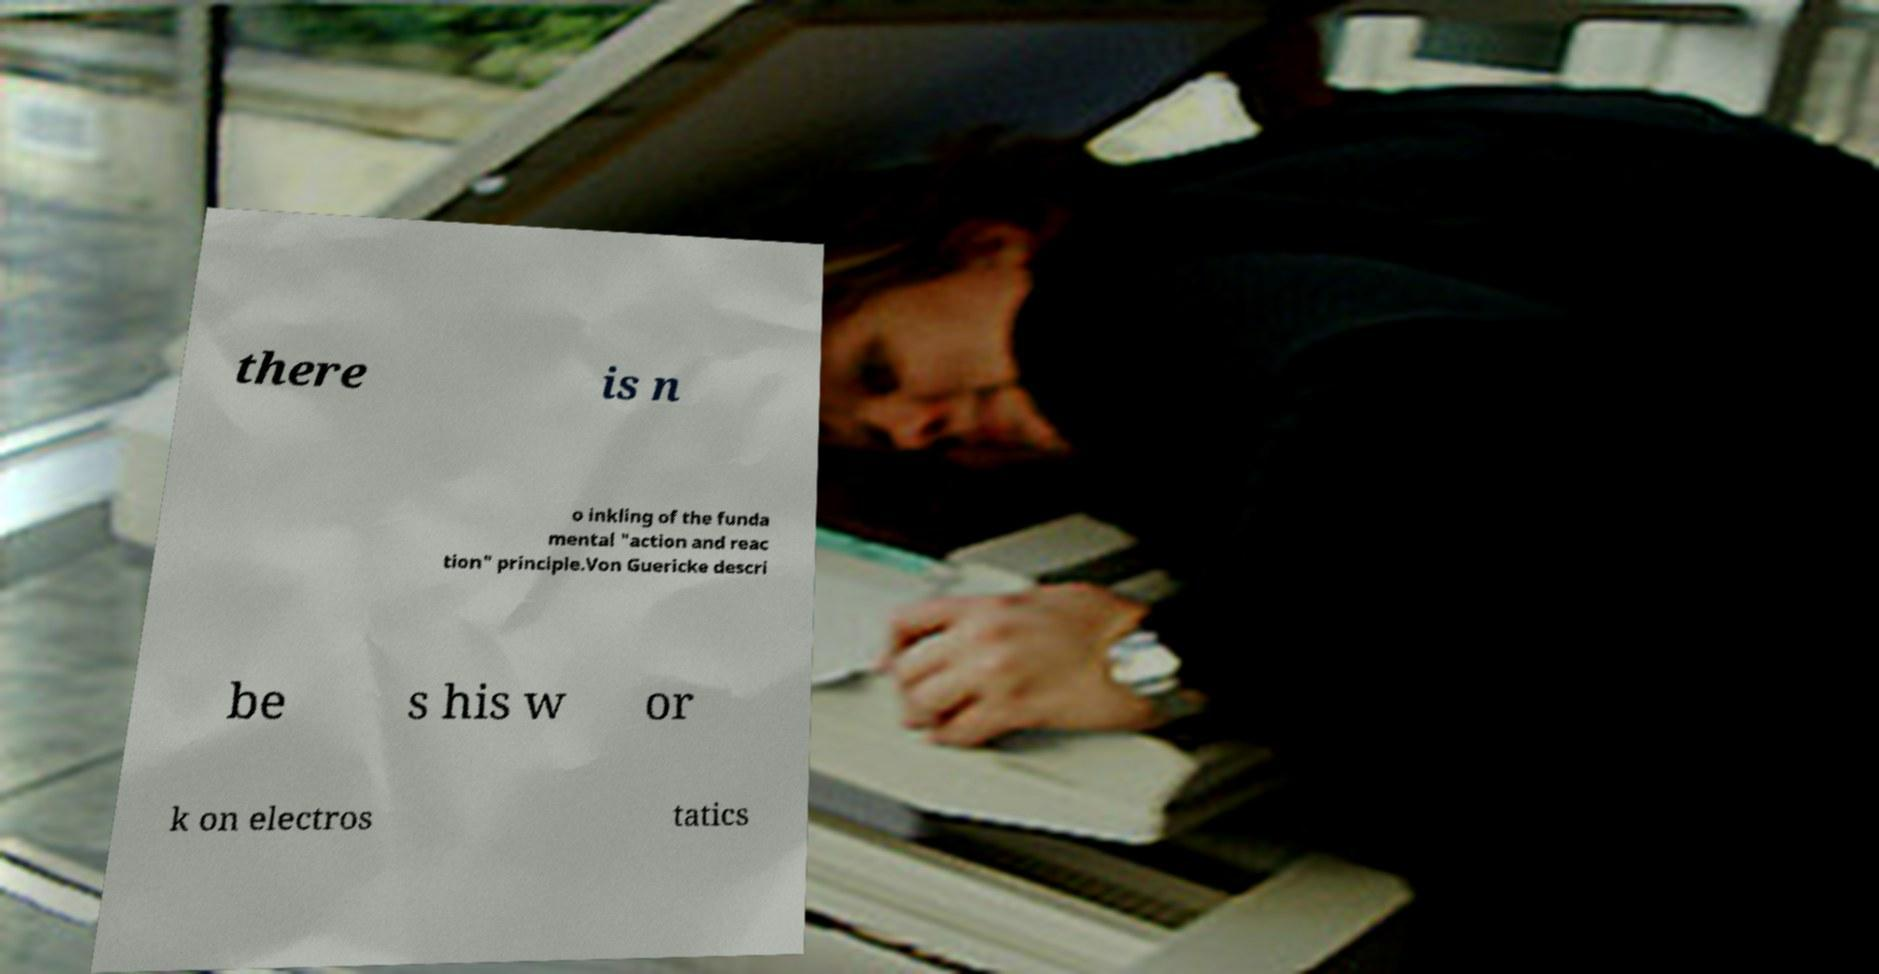Please read and relay the text visible in this image. What does it say? there is n o inkling of the funda mental "action and reac tion" principle.Von Guericke descri be s his w or k on electros tatics 